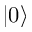Convert formula to latex. <formula><loc_0><loc_0><loc_500><loc_500>| 0 \rangle</formula> 